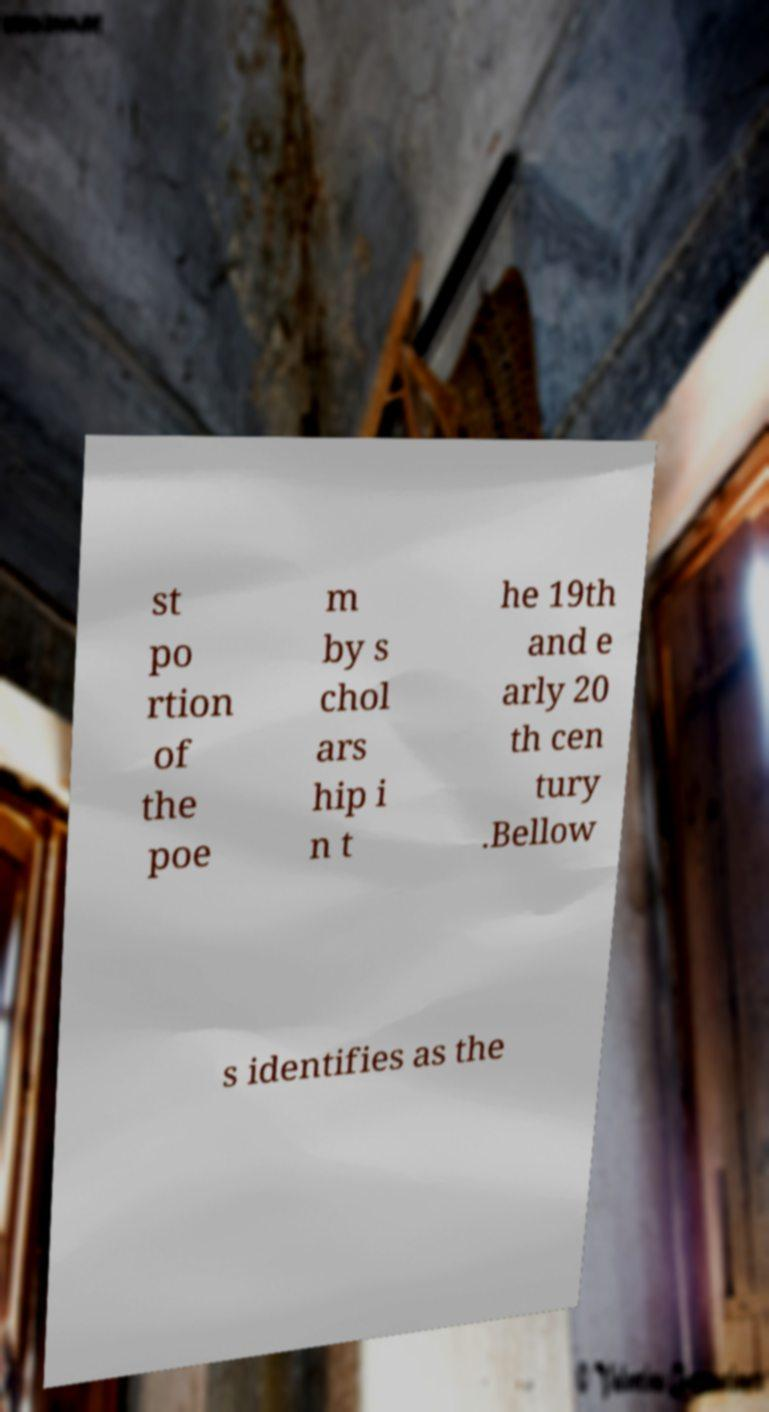Please read and relay the text visible in this image. What does it say? st po rtion of the poe m by s chol ars hip i n t he 19th and e arly 20 th cen tury .Bellow s identifies as the 